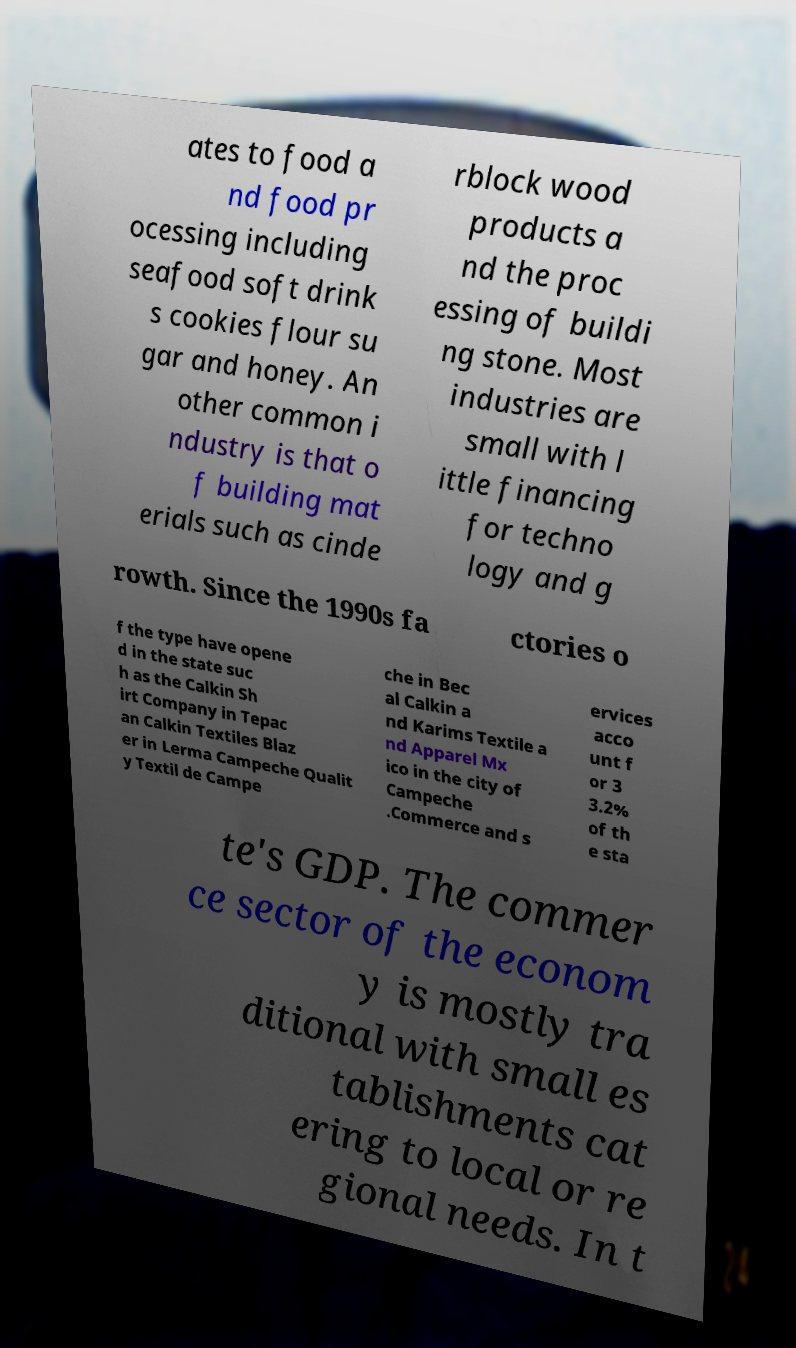Could you assist in decoding the text presented in this image and type it out clearly? ates to food a nd food pr ocessing including seafood soft drink s cookies flour su gar and honey. An other common i ndustry is that o f building mat erials such as cinde rblock wood products a nd the proc essing of buildi ng stone. Most industries are small with l ittle financing for techno logy and g rowth. Since the 1990s fa ctories o f the type have opene d in the state suc h as the Calkin Sh irt Company in Tepac an Calkin Textiles Blaz er in Lerma Campeche Qualit y Textil de Campe che in Bec al Calkin a nd Karims Textile a nd Apparel Mx ico in the city of Campeche .Commerce and s ervices acco unt f or 3 3.2% of th e sta te's GDP. The commer ce sector of the econom y is mostly tra ditional with small es tablishments cat ering to local or re gional needs. In t 